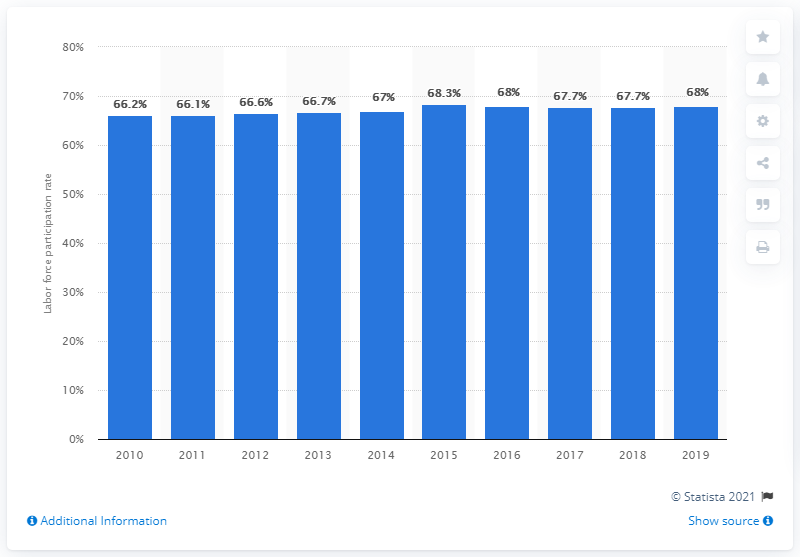Draw attention to some important aspects in this diagram. In 2019, the labor force participation rate in Singapore was 68%. 